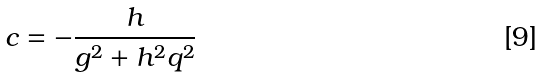<formula> <loc_0><loc_0><loc_500><loc_500>c = - \frac { h } { g ^ { 2 } + h ^ { 2 } q ^ { 2 } }</formula> 